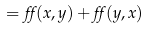<formula> <loc_0><loc_0><loc_500><loc_500>= \alpha ( x , y ) + \alpha ( y , x )</formula> 